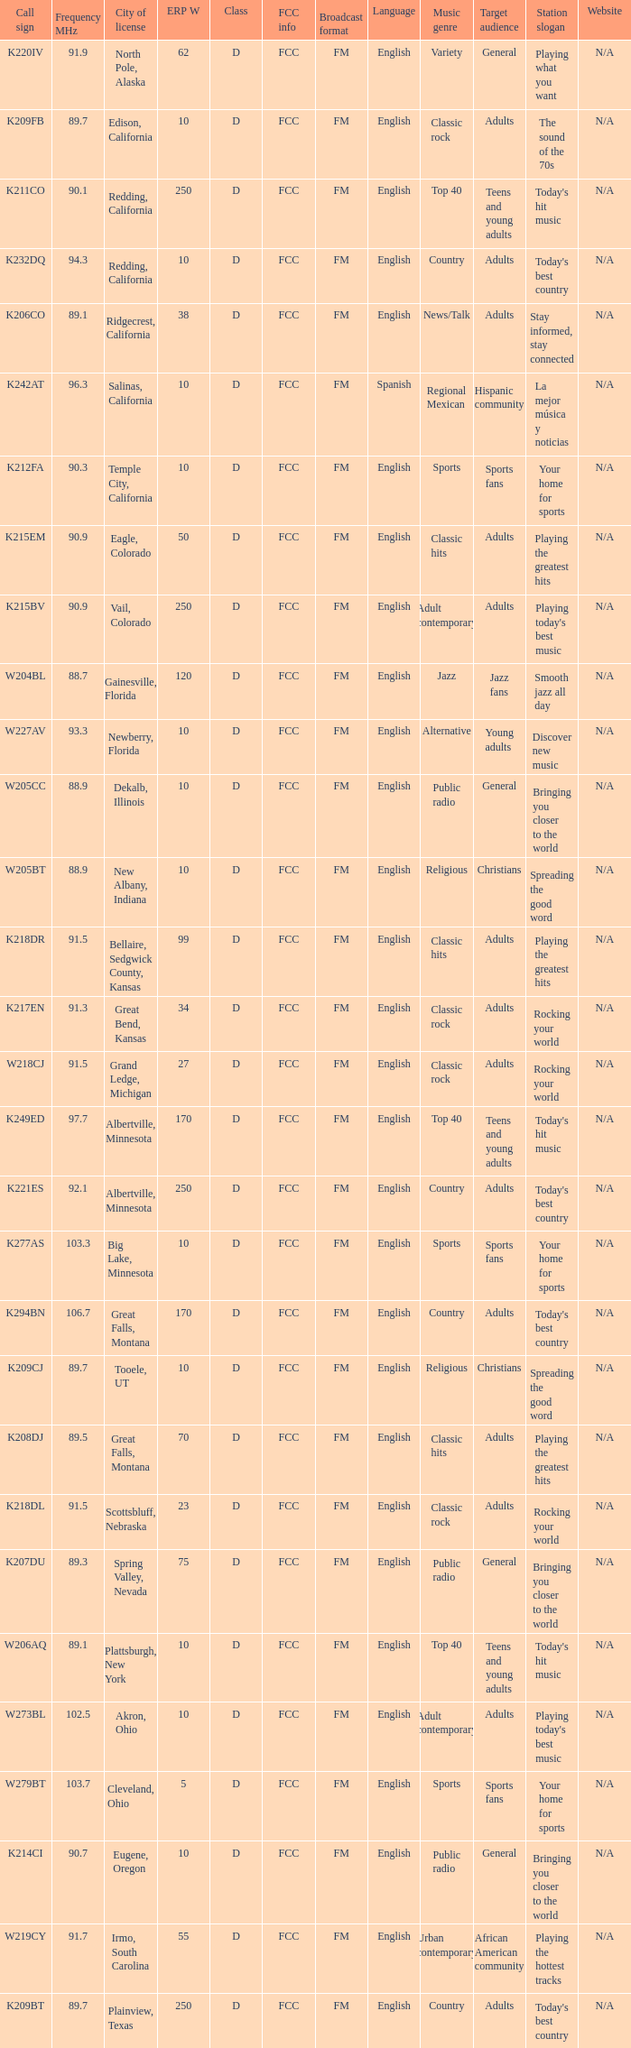What is the call sign of the translator with an ERP W greater than 38 and a city license from Great Falls, Montana? K294BN, K208DJ. 